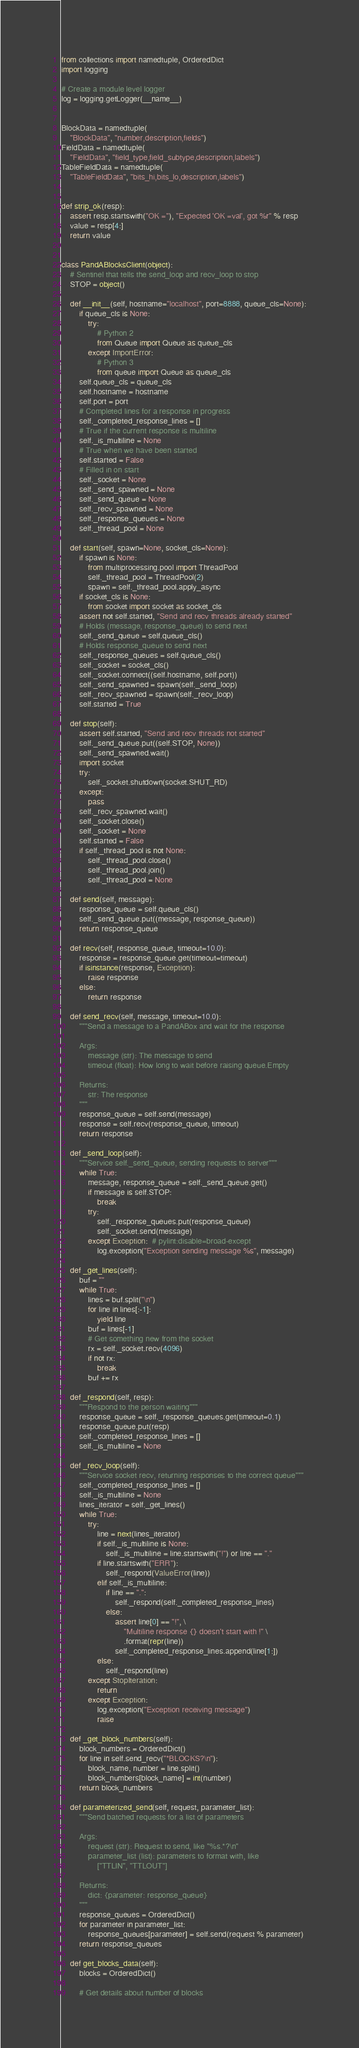Convert code to text. <code><loc_0><loc_0><loc_500><loc_500><_Python_>from collections import namedtuple, OrderedDict
import logging

# Create a module level logger
log = logging.getLogger(__name__)


BlockData = namedtuple(
    "BlockData", "number,description,fields")
FieldData = namedtuple(
    "FieldData", "field_type,field_subtype,description,labels")
TableFieldData = namedtuple(
    "TableFieldData", "bits_hi,bits_lo,description,labels")


def strip_ok(resp):
    assert resp.startswith("OK ="), "Expected 'OK =val', got %r" % resp
    value = resp[4:]
    return value


class PandABlocksClient(object):
    # Sentinel that tells the send_loop and recv_loop to stop
    STOP = object()
    
    def __init__(self, hostname="localhost", port=8888, queue_cls=None):
        if queue_cls is None:
            try:
                # Python 2
                from Queue import Queue as queue_cls
            except ImportError:
                # Python 3
                from queue import Queue as queue_cls
        self.queue_cls = queue_cls
        self.hostname = hostname
        self.port = port
        # Completed lines for a response in progress
        self._completed_response_lines = []
        # True if the current response is multiline
        self._is_multiline = None
        # True when we have been started
        self.started = False
        # Filled in on start
        self._socket = None
        self._send_spawned = None
        self._send_queue = None
        self._recv_spawned = None
        self._response_queues = None
        self._thread_pool = None

    def start(self, spawn=None, socket_cls=None):
        if spawn is None:
            from multiprocessing.pool import ThreadPool
            self._thread_pool = ThreadPool(2)
            spawn = self._thread_pool.apply_async
        if socket_cls is None:
            from socket import socket as socket_cls
        assert not self.started, "Send and recv threads already started"
        # Holds (message, response_queue) to send next
        self._send_queue = self.queue_cls()
        # Holds response_queue to send next
        self._response_queues = self.queue_cls()
        self._socket = socket_cls()
        self._socket.connect((self.hostname, self.port))
        self._send_spawned = spawn(self._send_loop)
        self._recv_spawned = spawn(self._recv_loop)
        self.started = True
        
    def stop(self):
        assert self.started, "Send and recv threads not started"
        self._send_queue.put((self.STOP, None))    
        self._send_spawned.wait()
        import socket
        try:
            self._socket.shutdown(socket.SHUT_RD)
        except:
            pass
        self._recv_spawned.wait()
        self._socket.close()
        self._socket = None
        self.started = False
        if self._thread_pool is not None:
            self._thread_pool.close()
            self._thread_pool.join()
            self._thread_pool = None

    def send(self, message):
        response_queue = self.queue_cls()
        self._send_queue.put((message, response_queue))
        return response_queue

    def recv(self, response_queue, timeout=10.0):
        response = response_queue.get(timeout=timeout)
        if isinstance(response, Exception):
            raise response
        else:
            return response

    def send_recv(self, message, timeout=10.0):
        """Send a message to a PandABox and wait for the response

        Args:
            message (str): The message to send
            timeout (float): How long to wait before raising queue.Empty

        Returns:
            str: The response
        """
        response_queue = self.send(message)
        response = self.recv(response_queue, timeout)
        return response

    def _send_loop(self):
        """Service self._send_queue, sending requests to server"""
        while True:
            message, response_queue = self._send_queue.get()
            if message is self.STOP:
                break
            try:
                self._response_queues.put(response_queue)
                self._socket.send(message)
            except Exception:  # pylint:disable=broad-except
                log.exception("Exception sending message %s", message)

    def _get_lines(self):
        buf = ""
        while True:
            lines = buf.split("\n")
            for line in lines[:-1]:
                yield line
            buf = lines[-1]
            # Get something new from the socket
            rx = self._socket.recv(4096)
            if not rx:
                break
            buf += rx

    def _respond(self, resp):
        """Respond to the person waiting"""
        response_queue = self._response_queues.get(timeout=0.1)
        response_queue.put(resp)
        self._completed_response_lines = []
        self._is_multiline = None

    def _recv_loop(self):
        """Service socket recv, returning responses to the correct queue"""
        self._completed_response_lines = []
        self._is_multiline = None
        lines_iterator = self._get_lines()
        while True:
            try:
                line = next(lines_iterator)
                if self._is_multiline is None:
                    self._is_multiline = line.startswith("!") or line == "."
                if line.startswith("ERR"):
                    self._respond(ValueError(line))
                elif self._is_multiline:
                    if line == ".":
                        self._respond(self._completed_response_lines)
                    else:
                        assert line[0] == "!", \
                            "Multiline response {} doesn't start with !" \
                            .format(repr(line))
                        self._completed_response_lines.append(line[1:])
                else:
                    self._respond(line)
            except StopIteration:
                return
            except Exception:
                log.exception("Exception receiving message")
                raise

    def _get_block_numbers(self):
        block_numbers = OrderedDict()
        for line in self.send_recv("*BLOCKS?\n"):
            block_name, number = line.split()
            block_numbers[block_name] = int(number)
        return block_numbers

    def parameterized_send(self, request, parameter_list):
        """Send batched requests for a list of parameters

        Args:
            request (str): Request to send, like "%s.*?\n"
            parameter_list (list): parameters to format with, like
                ["TTLIN", "TTLOUT"]

        Returns:
            dict: {parameter: response_queue}
        """
        response_queues = OrderedDict()
        for parameter in parameter_list:
            response_queues[parameter] = self.send(request % parameter)
        return response_queues

    def get_blocks_data(self):
        blocks = OrderedDict()

        # Get details about number of blocks</code> 